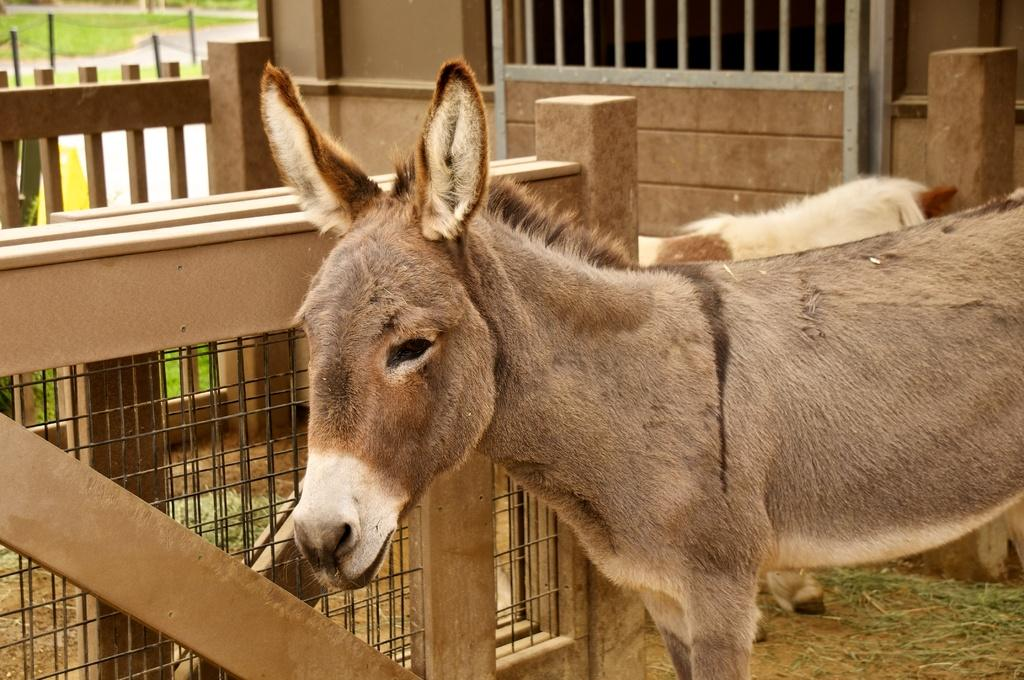What type of animal is present in the image? There is a donkey in the image. What color is the donkey? The donkey is brown in color. What is the purpose of the iron net in the image? The purpose of the iron net is not specified in the facts provided. How many sisters are present in the image? There are no sisters mentioned or depicted in the image. What type of sorting activity is taking place in the image? There is no sorting activity present in the image. 